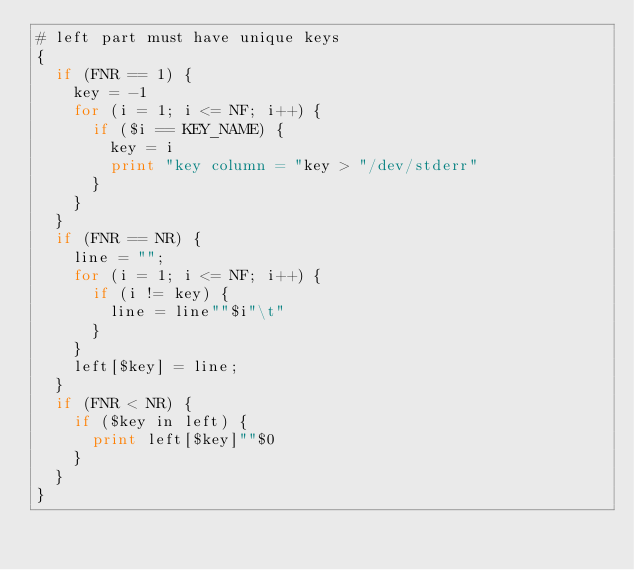Convert code to text. <code><loc_0><loc_0><loc_500><loc_500><_Awk_># left part must have unique keys
{ 
	if (FNR == 1) {
		key = -1
		for (i = 1; i <= NF; i++) {
			if ($i == KEY_NAME) {
				key = i
				print "key column = "key > "/dev/stderr"
			}
		}
	}
	if (FNR == NR) {
		line = "";
		for (i = 1; i <= NF; i++) {
			if (i != key) {
				line = line""$i"\t"
			}
		}
		left[$key] = line;
	}
	if (FNR < NR) {
		if ($key in left) {
			print left[$key]""$0
		}
	}
}
</code> 